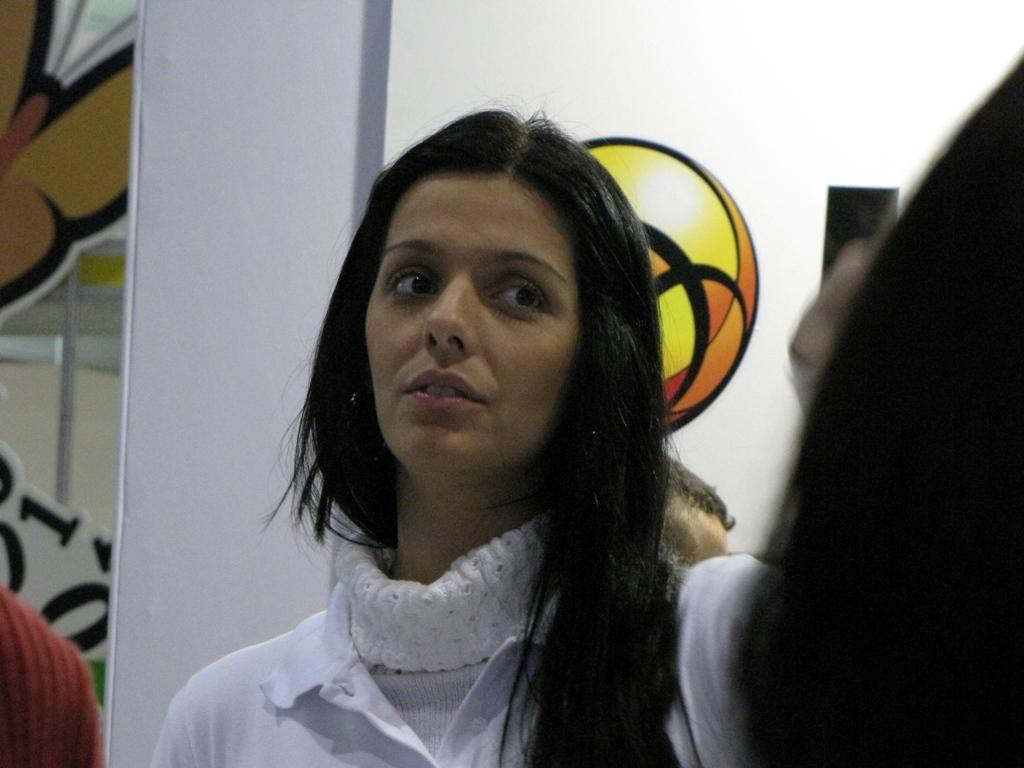Who is present in the image? There is a woman in the image. What is the woman wearing? The woman is wearing a white shirt. What can be seen in the background of the image? There is a wall in the background of the image. Are there any additional details on the wall? Yes, there is a sticker on the wall. What type of liquid is being poured from the yak in the image? There is no yak or liquid present in the image. Is there a tub visible in the image? No, there is no tub visible in the image. 